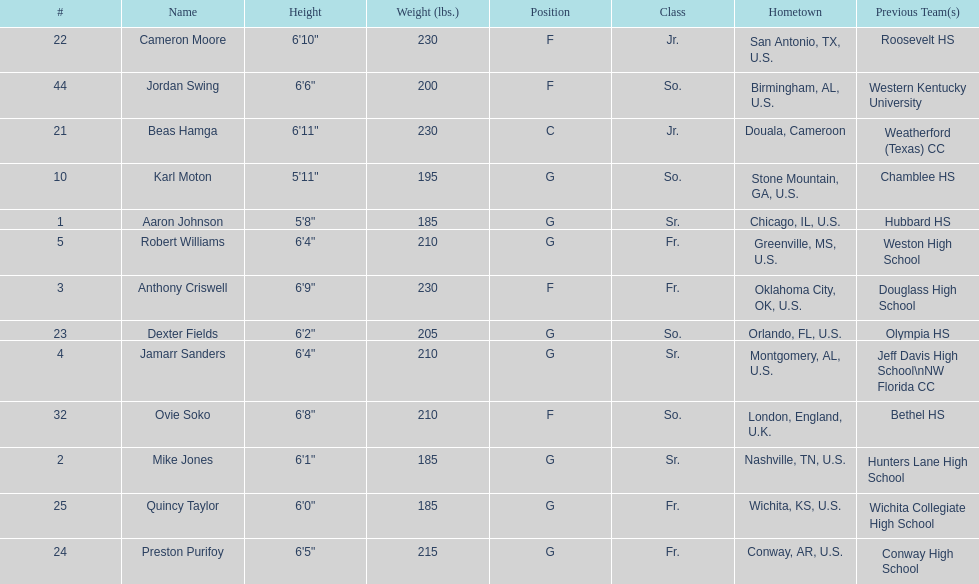Other than soko, tell me a player who is not from the us. Beas Hamga. 